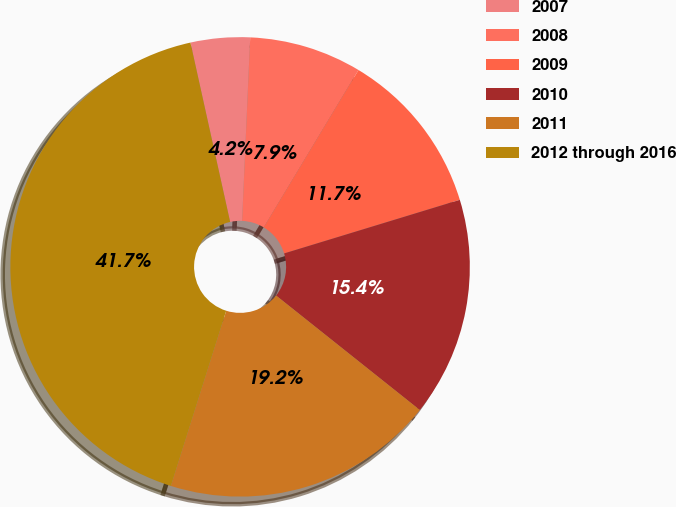<chart> <loc_0><loc_0><loc_500><loc_500><pie_chart><fcel>2007<fcel>2008<fcel>2009<fcel>2010<fcel>2011<fcel>2012 through 2016<nl><fcel>4.17%<fcel>7.92%<fcel>11.67%<fcel>15.42%<fcel>19.17%<fcel>41.67%<nl></chart> 